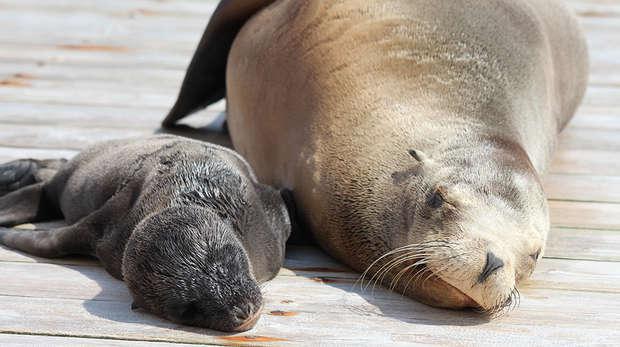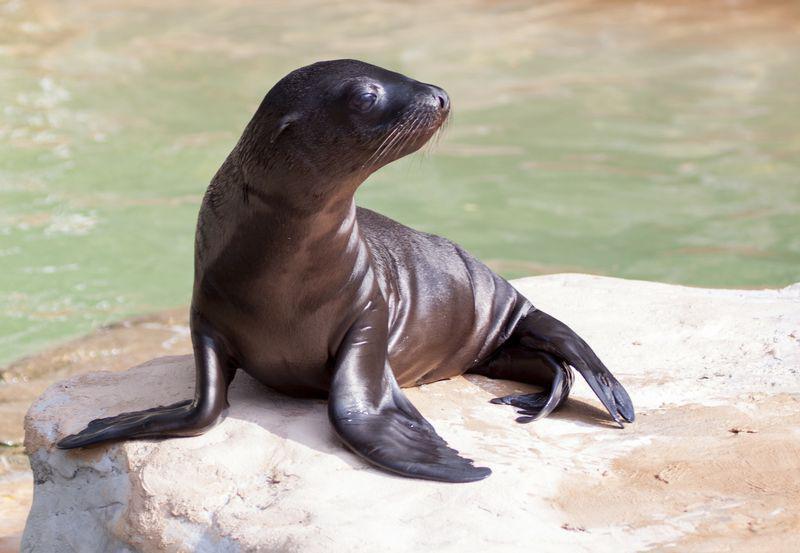The first image is the image on the left, the second image is the image on the right. Evaluate the accuracy of this statement regarding the images: "One image contains a single seal with head and shoulders upright, and the other image contains exactly two seals in the same scene together.". Is it true? Answer yes or no. Yes. The first image is the image on the left, the second image is the image on the right. Evaluate the accuracy of this statement regarding the images: "There are exactly three sea lions in total.". Is it true? Answer yes or no. Yes. 